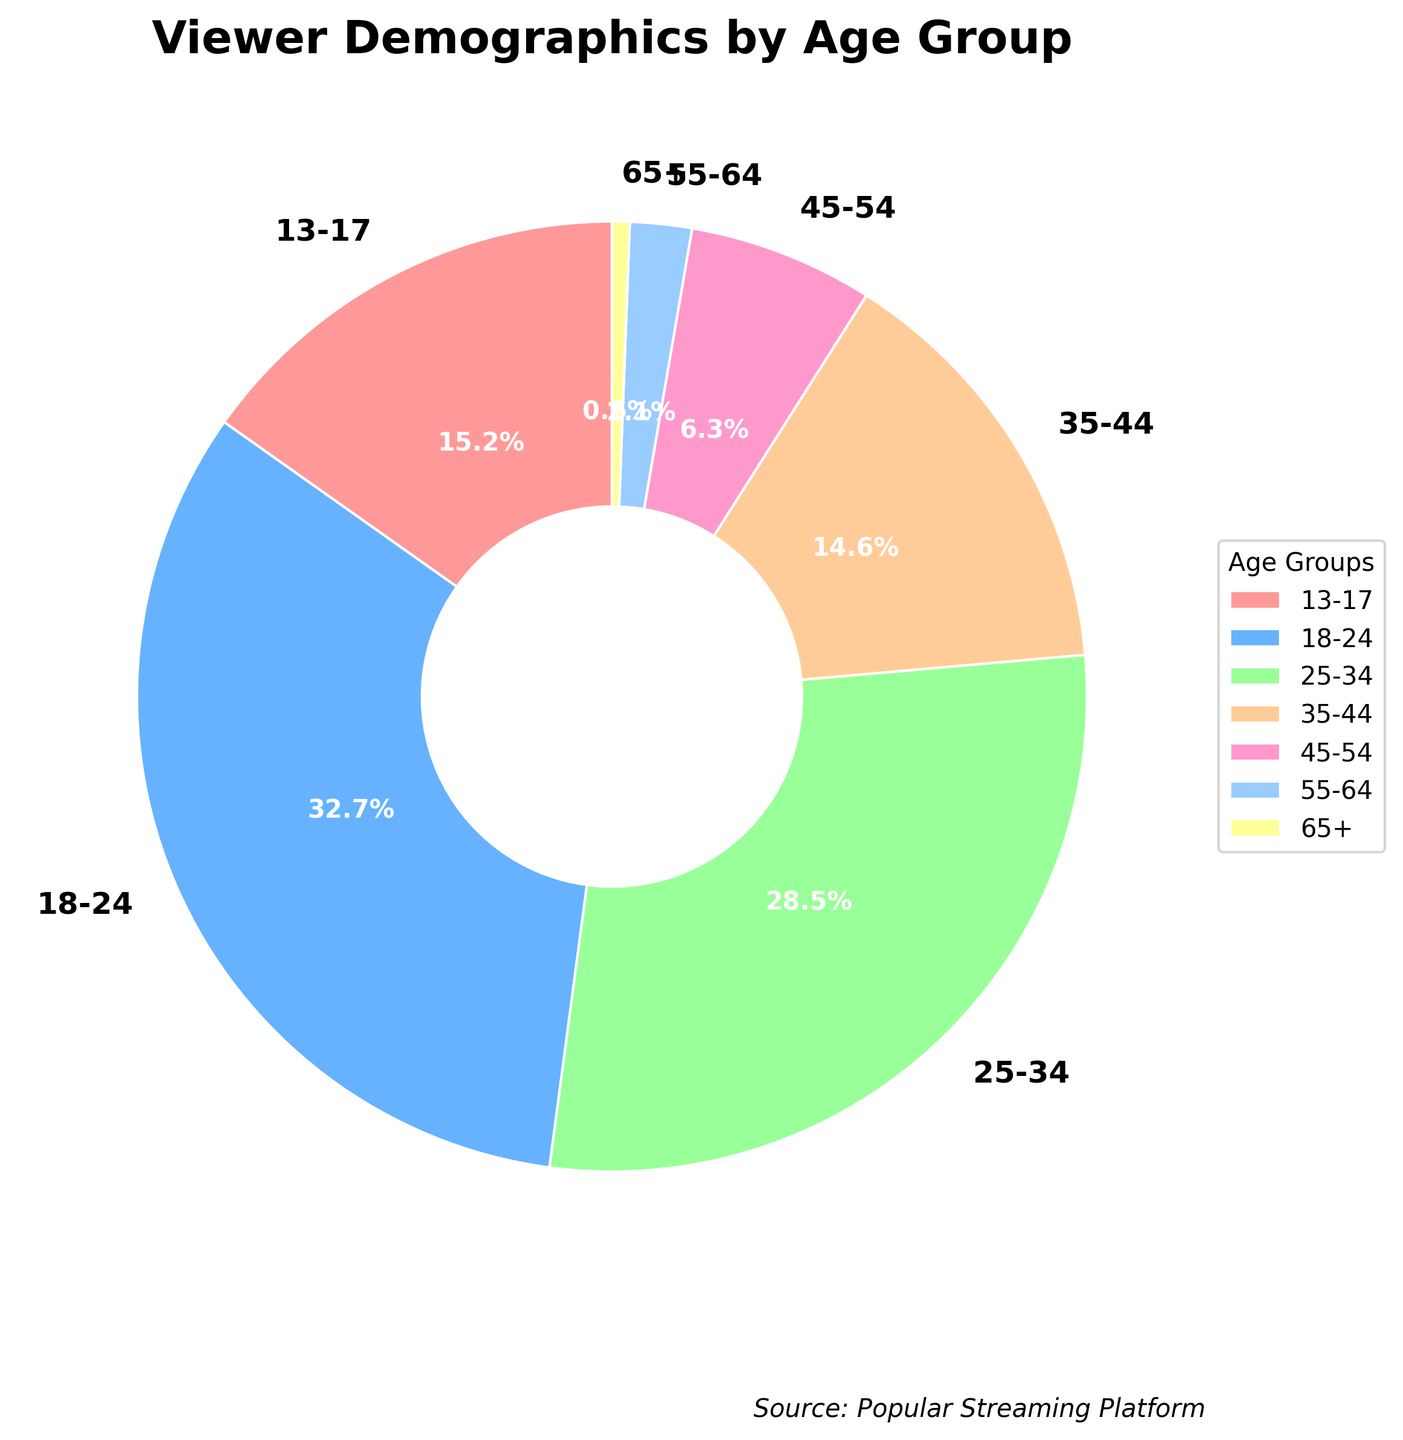What is the percentage of viewers aged 18-24? Look at the section of the pie chart labeled "18-24". The label indicates that this age group comprises 32.7% of the viewers.
Answer: 32.7% What is the sum of the percentages for viewers aged 13-17 and 55-64? First, identify the percentages for the 13-17 and 55-64 age groups from the pie chart, which are 15.2% and 2.1% respectively. Add these two percentages together: 15.2% + 2.1% = 17.3%.
Answer: 17.3% Which age group has the smallest share of viewers? Examine the labels on the pie chart to determine which age group has the smallest percentage. The 65+ age group has the smallest share with 0.6%.
Answer: 65+ How does the percentage of viewers aged 35-44 compare to those aged 25-34? Look at the pie chart and find the percentages for the 35-44 and 25-34 age groups. The 35-44 age group has 14.6%, while the 25-34 age group has 28.5%. 14.6% is smaller than 28.5%.
Answer: 25-34 is larger What is the combined percentage for viewers aged 35-54? Find the percentages for the 35-44 and 45-54 age groups, which are 14.6% and 6.3% respectively. Add these percentages together: 14.6% + 6.3% = 20.9%.
Answer: 20.9% Which age group has the second largest viewer percentage, and what color represents it on the pie chart? Look through the pie chart and find the second largest percentage which is for the age group 25-34 at 28.5%. The color representing this age group is shown on the chart as green.
Answer: 25-34, green If you combine the percentages of the two smallest age groups, what is the resulting percentage? First identify the two smallest age groups which are 65+ (0.6%) and 55-64 (2.1%). Adding these together gives 0.6% + 2.1% = 2.7%.
Answer: 2.7% Is there an age group with a percentage close to the combined length of the 13-17 and 35-44 age groups? First calculate the combined percentage of 13-17 and 35-44, which is 15.2% + 14.6% = 29.8%. Then identify if any age group is close to this value in the pie chart. The 25-34 age group with 28.5% is close.
Answer: 25-34 